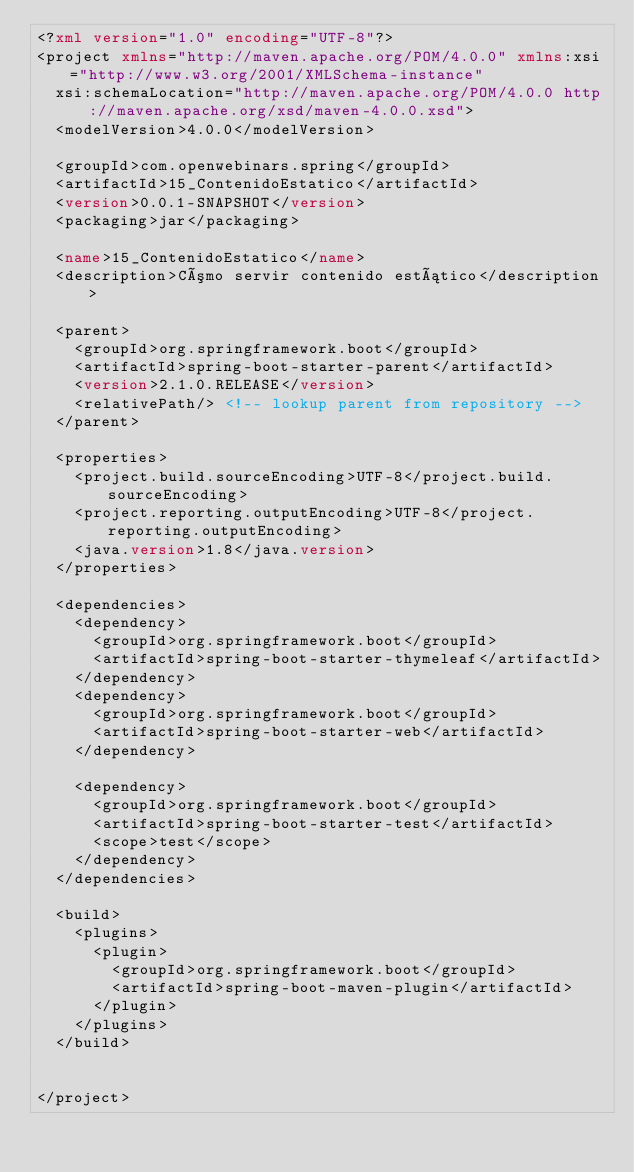<code> <loc_0><loc_0><loc_500><loc_500><_XML_><?xml version="1.0" encoding="UTF-8"?>
<project xmlns="http://maven.apache.org/POM/4.0.0" xmlns:xsi="http://www.w3.org/2001/XMLSchema-instance"
	xsi:schemaLocation="http://maven.apache.org/POM/4.0.0 http://maven.apache.org/xsd/maven-4.0.0.xsd">
	<modelVersion>4.0.0</modelVersion>

	<groupId>com.openwebinars.spring</groupId>
	<artifactId>15_ContenidoEstatico</artifactId>
	<version>0.0.1-SNAPSHOT</version>
	<packaging>jar</packaging>

	<name>15_ContenidoEstatico</name>
	<description>Cómo servir contenido estático</description>

	<parent>
		<groupId>org.springframework.boot</groupId>
		<artifactId>spring-boot-starter-parent</artifactId>
		<version>2.1.0.RELEASE</version>
		<relativePath/> <!-- lookup parent from repository -->
	</parent>

	<properties>
		<project.build.sourceEncoding>UTF-8</project.build.sourceEncoding>
		<project.reporting.outputEncoding>UTF-8</project.reporting.outputEncoding>
		<java.version>1.8</java.version>
	</properties>

	<dependencies>
		<dependency>
			<groupId>org.springframework.boot</groupId>
			<artifactId>spring-boot-starter-thymeleaf</artifactId>
		</dependency>
		<dependency>
			<groupId>org.springframework.boot</groupId>
			<artifactId>spring-boot-starter-web</artifactId>
		</dependency>

		<dependency>
			<groupId>org.springframework.boot</groupId>
			<artifactId>spring-boot-starter-test</artifactId>
			<scope>test</scope>
		</dependency>
	</dependencies>

	<build>
		<plugins>
			<plugin>
				<groupId>org.springframework.boot</groupId>
				<artifactId>spring-boot-maven-plugin</artifactId>
			</plugin>
		</plugins>
	</build>


</project>
</code> 